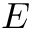Convert formula to latex. <formula><loc_0><loc_0><loc_500><loc_500>E</formula> 